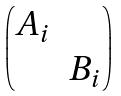Convert formula to latex. <formula><loc_0><loc_0><loc_500><loc_500>\begin{pmatrix} A _ { i } \\ & B _ { i } \end{pmatrix}</formula> 